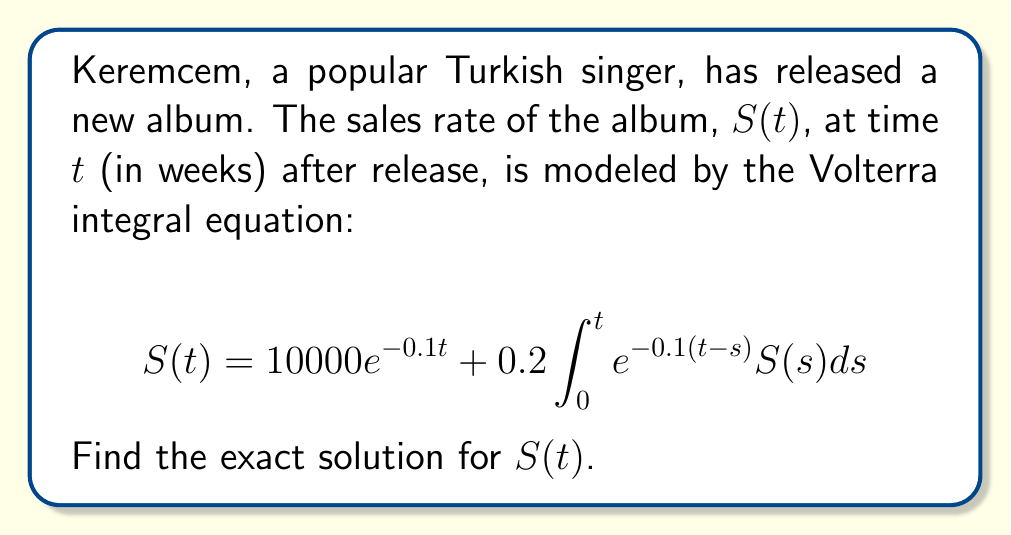Can you answer this question? To solve this Volterra integral equation, we'll use the Laplace transform method:

1) Take the Laplace transform of both sides:
   $$\mathcal{L}\{S(t)\} = \mathcal{L}\{10000e^{-0.1t}\} + 0.2\mathcal{L}\{\int_0^t e^{-0.1(t-s)}S(s)ds\}$$

2) Let $\mathcal{L}\{S(t)\} = \bar{S}(p)$. Using Laplace transform properties:
   $$\bar{S}(p) = \frac{10000}{p+0.1} + 0.2 \cdot \frac{1}{p+0.1}\bar{S}(p)$$

3) Simplify:
   $$\bar{S}(p)(1 - \frac{0.2}{p+0.1}) = \frac{10000}{p+0.1}$$
   $$\bar{S}(p) = \frac{10000}{p+0.1} \cdot \frac{1}{1 - \frac{0.2}{p+0.1}}$$

4) Simplify further:
   $$\bar{S}(p) = \frac{10000}{p+0.1} \cdot \frac{p+0.1}{p-0.1}$$
   $$\bar{S}(p) = \frac{10000}{p-0.1}$$

5) Take the inverse Laplace transform:
   $$S(t) = 10000e^{0.1t}$$

This is the exact solution for the album sales rate function $S(t)$.
Answer: $S(t) = 10000e^{0.1t}$ 